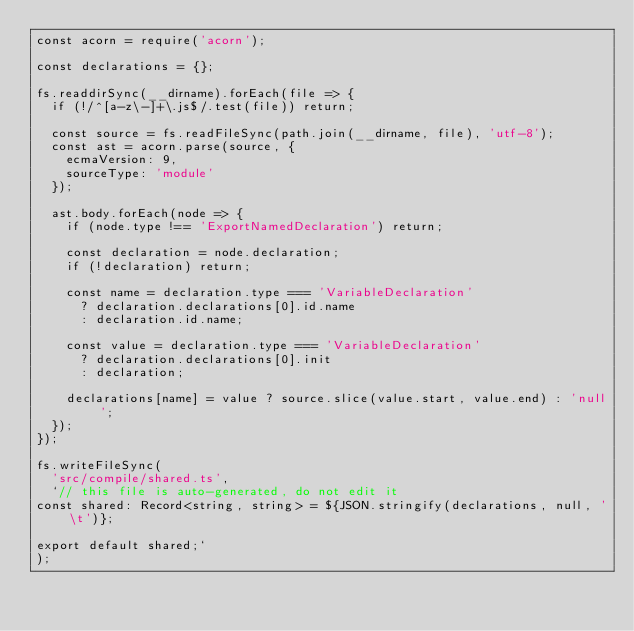Convert code to text. <code><loc_0><loc_0><loc_500><loc_500><_JavaScript_>const acorn = require('acorn');

const declarations = {};

fs.readdirSync(__dirname).forEach(file => {
	if (!/^[a-z\-]+\.js$/.test(file)) return;

	const source = fs.readFileSync(path.join(__dirname, file), 'utf-8');
	const ast = acorn.parse(source, {
		ecmaVersion: 9,
		sourceType: 'module'
	});

	ast.body.forEach(node => {
		if (node.type !== 'ExportNamedDeclaration') return;

		const declaration = node.declaration;
		if (!declaration) return;

		const name = declaration.type === 'VariableDeclaration'
			? declaration.declarations[0].id.name
			: declaration.id.name;

		const value = declaration.type === 'VariableDeclaration'
			? declaration.declarations[0].init
			: declaration;

		declarations[name] = value ? source.slice(value.start, value.end) : 'null';
	});
});

fs.writeFileSync(
	'src/compile/shared.ts',
	`// this file is auto-generated, do not edit it
const shared: Record<string, string> = ${JSON.stringify(declarations, null, '\t')};

export default shared;`
);
</code> 